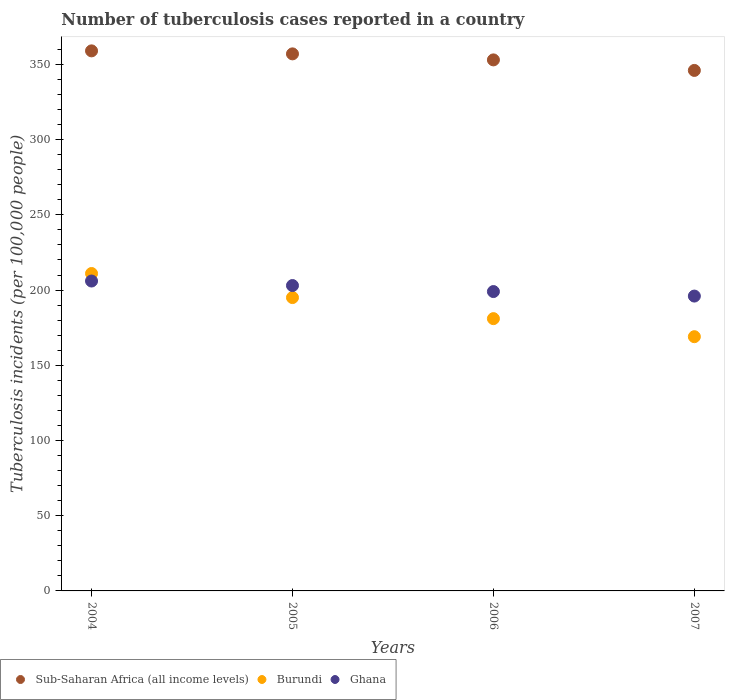What is the number of tuberculosis cases reported in in Sub-Saharan Africa (all income levels) in 2005?
Provide a short and direct response. 357. Across all years, what is the maximum number of tuberculosis cases reported in in Ghana?
Provide a short and direct response. 206. Across all years, what is the minimum number of tuberculosis cases reported in in Sub-Saharan Africa (all income levels)?
Make the answer very short. 346. In which year was the number of tuberculosis cases reported in in Sub-Saharan Africa (all income levels) maximum?
Your answer should be compact. 2004. In which year was the number of tuberculosis cases reported in in Ghana minimum?
Your answer should be very brief. 2007. What is the total number of tuberculosis cases reported in in Ghana in the graph?
Your answer should be very brief. 804. What is the difference between the number of tuberculosis cases reported in in Sub-Saharan Africa (all income levels) in 2005 and that in 2006?
Your answer should be very brief. 4. What is the difference between the number of tuberculosis cases reported in in Sub-Saharan Africa (all income levels) in 2006 and the number of tuberculosis cases reported in in Burundi in 2005?
Keep it short and to the point. 158. What is the average number of tuberculosis cases reported in in Ghana per year?
Your response must be concise. 201. In the year 2004, what is the difference between the number of tuberculosis cases reported in in Sub-Saharan Africa (all income levels) and number of tuberculosis cases reported in in Burundi?
Your response must be concise. 148. What is the ratio of the number of tuberculosis cases reported in in Ghana in 2006 to that in 2007?
Provide a short and direct response. 1.02. What is the difference between the highest and the second highest number of tuberculosis cases reported in in Ghana?
Your answer should be compact. 3. What is the difference between the highest and the lowest number of tuberculosis cases reported in in Burundi?
Your response must be concise. 42. In how many years, is the number of tuberculosis cases reported in in Sub-Saharan Africa (all income levels) greater than the average number of tuberculosis cases reported in in Sub-Saharan Africa (all income levels) taken over all years?
Make the answer very short. 2. Is the sum of the number of tuberculosis cases reported in in Sub-Saharan Africa (all income levels) in 2005 and 2007 greater than the maximum number of tuberculosis cases reported in in Ghana across all years?
Ensure brevity in your answer.  Yes. Is the number of tuberculosis cases reported in in Ghana strictly greater than the number of tuberculosis cases reported in in Burundi over the years?
Provide a short and direct response. No. Is the number of tuberculosis cases reported in in Ghana strictly less than the number of tuberculosis cases reported in in Burundi over the years?
Offer a very short reply. No. How many dotlines are there?
Offer a very short reply. 3. How many years are there in the graph?
Keep it short and to the point. 4. What is the difference between two consecutive major ticks on the Y-axis?
Provide a succinct answer. 50. Are the values on the major ticks of Y-axis written in scientific E-notation?
Make the answer very short. No. Does the graph contain grids?
Provide a succinct answer. No. How many legend labels are there?
Offer a very short reply. 3. What is the title of the graph?
Keep it short and to the point. Number of tuberculosis cases reported in a country. Does "Mali" appear as one of the legend labels in the graph?
Offer a terse response. No. What is the label or title of the X-axis?
Keep it short and to the point. Years. What is the label or title of the Y-axis?
Make the answer very short. Tuberculosis incidents (per 100,0 people). What is the Tuberculosis incidents (per 100,000 people) in Sub-Saharan Africa (all income levels) in 2004?
Your answer should be very brief. 359. What is the Tuberculosis incidents (per 100,000 people) of Burundi in 2004?
Your answer should be compact. 211. What is the Tuberculosis incidents (per 100,000 people) in Ghana in 2004?
Your response must be concise. 206. What is the Tuberculosis incidents (per 100,000 people) in Sub-Saharan Africa (all income levels) in 2005?
Your answer should be compact. 357. What is the Tuberculosis incidents (per 100,000 people) of Burundi in 2005?
Give a very brief answer. 195. What is the Tuberculosis incidents (per 100,000 people) in Ghana in 2005?
Your response must be concise. 203. What is the Tuberculosis incidents (per 100,000 people) in Sub-Saharan Africa (all income levels) in 2006?
Make the answer very short. 353. What is the Tuberculosis incidents (per 100,000 people) in Burundi in 2006?
Ensure brevity in your answer.  181. What is the Tuberculosis incidents (per 100,000 people) in Ghana in 2006?
Offer a terse response. 199. What is the Tuberculosis incidents (per 100,000 people) in Sub-Saharan Africa (all income levels) in 2007?
Ensure brevity in your answer.  346. What is the Tuberculosis incidents (per 100,000 people) of Burundi in 2007?
Offer a very short reply. 169. What is the Tuberculosis incidents (per 100,000 people) of Ghana in 2007?
Offer a very short reply. 196. Across all years, what is the maximum Tuberculosis incidents (per 100,000 people) of Sub-Saharan Africa (all income levels)?
Keep it short and to the point. 359. Across all years, what is the maximum Tuberculosis incidents (per 100,000 people) of Burundi?
Provide a succinct answer. 211. Across all years, what is the maximum Tuberculosis incidents (per 100,000 people) of Ghana?
Your answer should be very brief. 206. Across all years, what is the minimum Tuberculosis incidents (per 100,000 people) of Sub-Saharan Africa (all income levels)?
Your answer should be compact. 346. Across all years, what is the minimum Tuberculosis incidents (per 100,000 people) of Burundi?
Make the answer very short. 169. Across all years, what is the minimum Tuberculosis incidents (per 100,000 people) of Ghana?
Ensure brevity in your answer.  196. What is the total Tuberculosis incidents (per 100,000 people) in Sub-Saharan Africa (all income levels) in the graph?
Make the answer very short. 1415. What is the total Tuberculosis incidents (per 100,000 people) of Burundi in the graph?
Provide a succinct answer. 756. What is the total Tuberculosis incidents (per 100,000 people) in Ghana in the graph?
Keep it short and to the point. 804. What is the difference between the Tuberculosis incidents (per 100,000 people) of Burundi in 2004 and that in 2005?
Offer a terse response. 16. What is the difference between the Tuberculosis incidents (per 100,000 people) in Ghana in 2004 and that in 2005?
Offer a very short reply. 3. What is the difference between the Tuberculosis incidents (per 100,000 people) of Burundi in 2004 and that in 2006?
Your answer should be very brief. 30. What is the difference between the Tuberculosis incidents (per 100,000 people) of Sub-Saharan Africa (all income levels) in 2004 and that in 2007?
Your response must be concise. 13. What is the difference between the Tuberculosis incidents (per 100,000 people) in Burundi in 2004 and that in 2007?
Ensure brevity in your answer.  42. What is the difference between the Tuberculosis incidents (per 100,000 people) of Ghana in 2004 and that in 2007?
Offer a very short reply. 10. What is the difference between the Tuberculosis incidents (per 100,000 people) of Sub-Saharan Africa (all income levels) in 2005 and that in 2006?
Make the answer very short. 4. What is the difference between the Tuberculosis incidents (per 100,000 people) in Sub-Saharan Africa (all income levels) in 2005 and that in 2007?
Your answer should be very brief. 11. What is the difference between the Tuberculosis incidents (per 100,000 people) of Ghana in 2005 and that in 2007?
Make the answer very short. 7. What is the difference between the Tuberculosis incidents (per 100,000 people) of Sub-Saharan Africa (all income levels) in 2006 and that in 2007?
Ensure brevity in your answer.  7. What is the difference between the Tuberculosis incidents (per 100,000 people) in Burundi in 2006 and that in 2007?
Provide a succinct answer. 12. What is the difference between the Tuberculosis incidents (per 100,000 people) of Sub-Saharan Africa (all income levels) in 2004 and the Tuberculosis incidents (per 100,000 people) of Burundi in 2005?
Your answer should be compact. 164. What is the difference between the Tuberculosis incidents (per 100,000 people) in Sub-Saharan Africa (all income levels) in 2004 and the Tuberculosis incidents (per 100,000 people) in Ghana in 2005?
Offer a terse response. 156. What is the difference between the Tuberculosis incidents (per 100,000 people) of Sub-Saharan Africa (all income levels) in 2004 and the Tuberculosis incidents (per 100,000 people) of Burundi in 2006?
Give a very brief answer. 178. What is the difference between the Tuberculosis incidents (per 100,000 people) in Sub-Saharan Africa (all income levels) in 2004 and the Tuberculosis incidents (per 100,000 people) in Ghana in 2006?
Give a very brief answer. 160. What is the difference between the Tuberculosis incidents (per 100,000 people) of Sub-Saharan Africa (all income levels) in 2004 and the Tuberculosis incidents (per 100,000 people) of Burundi in 2007?
Your answer should be very brief. 190. What is the difference between the Tuberculosis incidents (per 100,000 people) in Sub-Saharan Africa (all income levels) in 2004 and the Tuberculosis incidents (per 100,000 people) in Ghana in 2007?
Ensure brevity in your answer.  163. What is the difference between the Tuberculosis incidents (per 100,000 people) of Sub-Saharan Africa (all income levels) in 2005 and the Tuberculosis incidents (per 100,000 people) of Burundi in 2006?
Your answer should be very brief. 176. What is the difference between the Tuberculosis incidents (per 100,000 people) in Sub-Saharan Africa (all income levels) in 2005 and the Tuberculosis incidents (per 100,000 people) in Ghana in 2006?
Make the answer very short. 158. What is the difference between the Tuberculosis incidents (per 100,000 people) in Sub-Saharan Africa (all income levels) in 2005 and the Tuberculosis incidents (per 100,000 people) in Burundi in 2007?
Offer a terse response. 188. What is the difference between the Tuberculosis incidents (per 100,000 people) in Sub-Saharan Africa (all income levels) in 2005 and the Tuberculosis incidents (per 100,000 people) in Ghana in 2007?
Keep it short and to the point. 161. What is the difference between the Tuberculosis incidents (per 100,000 people) in Burundi in 2005 and the Tuberculosis incidents (per 100,000 people) in Ghana in 2007?
Give a very brief answer. -1. What is the difference between the Tuberculosis incidents (per 100,000 people) in Sub-Saharan Africa (all income levels) in 2006 and the Tuberculosis incidents (per 100,000 people) in Burundi in 2007?
Offer a terse response. 184. What is the difference between the Tuberculosis incidents (per 100,000 people) in Sub-Saharan Africa (all income levels) in 2006 and the Tuberculosis incidents (per 100,000 people) in Ghana in 2007?
Provide a succinct answer. 157. What is the difference between the Tuberculosis incidents (per 100,000 people) in Burundi in 2006 and the Tuberculosis incidents (per 100,000 people) in Ghana in 2007?
Offer a terse response. -15. What is the average Tuberculosis incidents (per 100,000 people) in Sub-Saharan Africa (all income levels) per year?
Give a very brief answer. 353.75. What is the average Tuberculosis incidents (per 100,000 people) in Burundi per year?
Offer a terse response. 189. What is the average Tuberculosis incidents (per 100,000 people) of Ghana per year?
Your answer should be very brief. 201. In the year 2004, what is the difference between the Tuberculosis incidents (per 100,000 people) in Sub-Saharan Africa (all income levels) and Tuberculosis incidents (per 100,000 people) in Burundi?
Keep it short and to the point. 148. In the year 2004, what is the difference between the Tuberculosis incidents (per 100,000 people) in Sub-Saharan Africa (all income levels) and Tuberculosis incidents (per 100,000 people) in Ghana?
Your answer should be compact. 153. In the year 2004, what is the difference between the Tuberculosis incidents (per 100,000 people) in Burundi and Tuberculosis incidents (per 100,000 people) in Ghana?
Provide a succinct answer. 5. In the year 2005, what is the difference between the Tuberculosis incidents (per 100,000 people) in Sub-Saharan Africa (all income levels) and Tuberculosis incidents (per 100,000 people) in Burundi?
Your response must be concise. 162. In the year 2005, what is the difference between the Tuberculosis incidents (per 100,000 people) in Sub-Saharan Africa (all income levels) and Tuberculosis incidents (per 100,000 people) in Ghana?
Your answer should be compact. 154. In the year 2006, what is the difference between the Tuberculosis incidents (per 100,000 people) of Sub-Saharan Africa (all income levels) and Tuberculosis incidents (per 100,000 people) of Burundi?
Provide a succinct answer. 172. In the year 2006, what is the difference between the Tuberculosis incidents (per 100,000 people) in Sub-Saharan Africa (all income levels) and Tuberculosis incidents (per 100,000 people) in Ghana?
Make the answer very short. 154. In the year 2006, what is the difference between the Tuberculosis incidents (per 100,000 people) in Burundi and Tuberculosis incidents (per 100,000 people) in Ghana?
Your answer should be compact. -18. In the year 2007, what is the difference between the Tuberculosis incidents (per 100,000 people) in Sub-Saharan Africa (all income levels) and Tuberculosis incidents (per 100,000 people) in Burundi?
Provide a succinct answer. 177. In the year 2007, what is the difference between the Tuberculosis incidents (per 100,000 people) in Sub-Saharan Africa (all income levels) and Tuberculosis incidents (per 100,000 people) in Ghana?
Make the answer very short. 150. What is the ratio of the Tuberculosis incidents (per 100,000 people) in Sub-Saharan Africa (all income levels) in 2004 to that in 2005?
Offer a terse response. 1.01. What is the ratio of the Tuberculosis incidents (per 100,000 people) in Burundi in 2004 to that in 2005?
Make the answer very short. 1.08. What is the ratio of the Tuberculosis incidents (per 100,000 people) of Ghana in 2004 to that in 2005?
Provide a succinct answer. 1.01. What is the ratio of the Tuberculosis incidents (per 100,000 people) of Burundi in 2004 to that in 2006?
Your response must be concise. 1.17. What is the ratio of the Tuberculosis incidents (per 100,000 people) in Ghana in 2004 to that in 2006?
Provide a short and direct response. 1.04. What is the ratio of the Tuberculosis incidents (per 100,000 people) of Sub-Saharan Africa (all income levels) in 2004 to that in 2007?
Give a very brief answer. 1.04. What is the ratio of the Tuberculosis incidents (per 100,000 people) in Burundi in 2004 to that in 2007?
Your answer should be very brief. 1.25. What is the ratio of the Tuberculosis incidents (per 100,000 people) in Ghana in 2004 to that in 2007?
Keep it short and to the point. 1.05. What is the ratio of the Tuberculosis incidents (per 100,000 people) in Sub-Saharan Africa (all income levels) in 2005 to that in 2006?
Provide a short and direct response. 1.01. What is the ratio of the Tuberculosis incidents (per 100,000 people) of Burundi in 2005 to that in 2006?
Provide a succinct answer. 1.08. What is the ratio of the Tuberculosis incidents (per 100,000 people) of Ghana in 2005 to that in 2006?
Your answer should be very brief. 1.02. What is the ratio of the Tuberculosis incidents (per 100,000 people) of Sub-Saharan Africa (all income levels) in 2005 to that in 2007?
Your answer should be compact. 1.03. What is the ratio of the Tuberculosis incidents (per 100,000 people) in Burundi in 2005 to that in 2007?
Offer a terse response. 1.15. What is the ratio of the Tuberculosis incidents (per 100,000 people) of Ghana in 2005 to that in 2007?
Offer a very short reply. 1.04. What is the ratio of the Tuberculosis incidents (per 100,000 people) in Sub-Saharan Africa (all income levels) in 2006 to that in 2007?
Make the answer very short. 1.02. What is the ratio of the Tuberculosis incidents (per 100,000 people) in Burundi in 2006 to that in 2007?
Offer a very short reply. 1.07. What is the ratio of the Tuberculosis incidents (per 100,000 people) of Ghana in 2006 to that in 2007?
Offer a very short reply. 1.02. What is the difference between the highest and the second highest Tuberculosis incidents (per 100,000 people) of Sub-Saharan Africa (all income levels)?
Ensure brevity in your answer.  2. What is the difference between the highest and the second highest Tuberculosis incidents (per 100,000 people) of Burundi?
Give a very brief answer. 16. What is the difference between the highest and the lowest Tuberculosis incidents (per 100,000 people) in Ghana?
Ensure brevity in your answer.  10. 